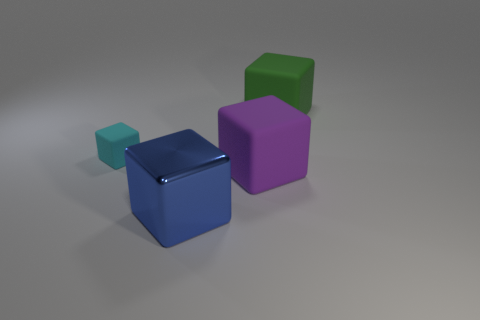Can you describe any unique features or differences among the cubes? Certainly! Each cube has a distinct size and color, which are their main differentiating features. The sizes scale from small to largest, going from the cyan, green, blue, and then to the purple cube. As for color, every cube appears to have a matte finish, contributing to the non-reflective aesthetic of their different colors.  Judging by the shadows, what can we say about the light source in this image? By examining the shadows, we can infer that the light source is located above and to the left of the cubes. This is indicated by the direction of the shadows extending to the right and slightly forward from each cube. 